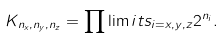Convert formula to latex. <formula><loc_0><loc_0><loc_500><loc_500>K _ { n _ { x } , n _ { y } , n _ { z } } = \prod \lim i t s _ { i = x , y , z } 2 ^ { n _ { i } } .</formula> 